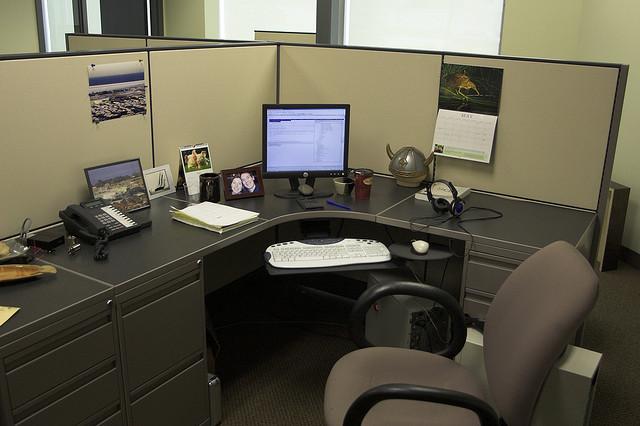What colors are on the screen?
Give a very brief answer. White. Is there a Viking helmet on the desk?
Be succinct. Yes. How many monitors are on the desk?
Concise answer only. 1. What is on the screen?
Quick response, please. Spreadsheet. Is the computer on?
Quick response, please. Yes. 